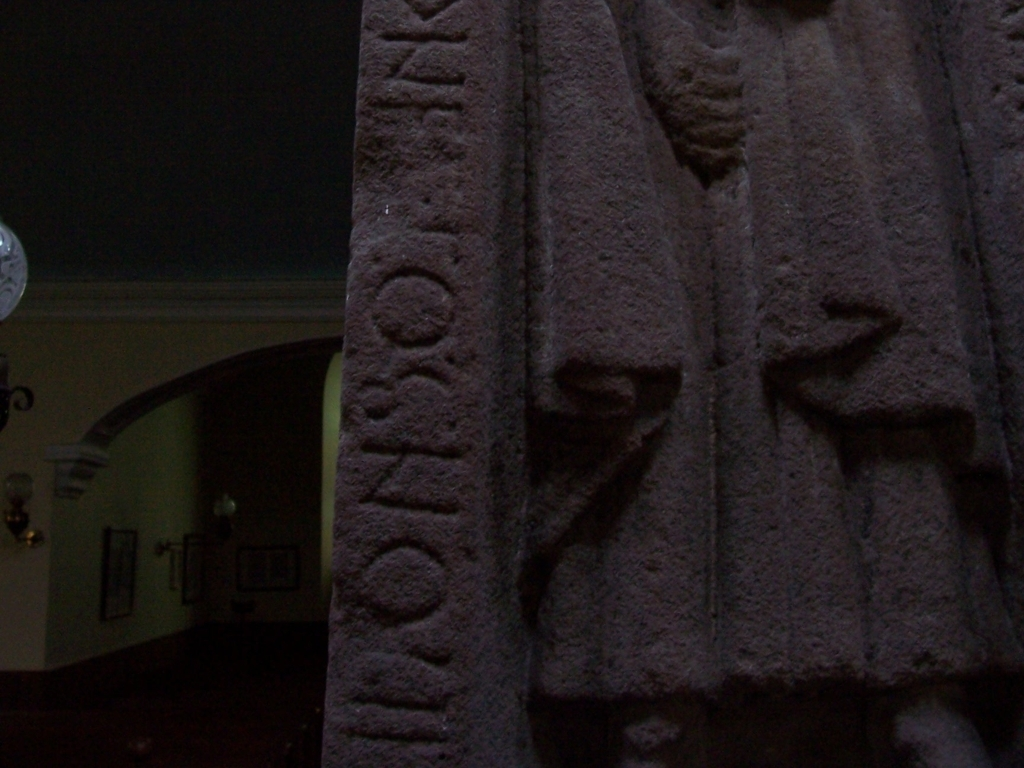Can you describe the style or historical period the carvings in this image might belong to? The relief carvings visible in the image appear to be characteristic of ancient or medieval stonework, potentially belonging to a historical period where such techniques were prominent. The use of capital letters and the weathered appearance suggest a considerable age for the inscription and the figures. 